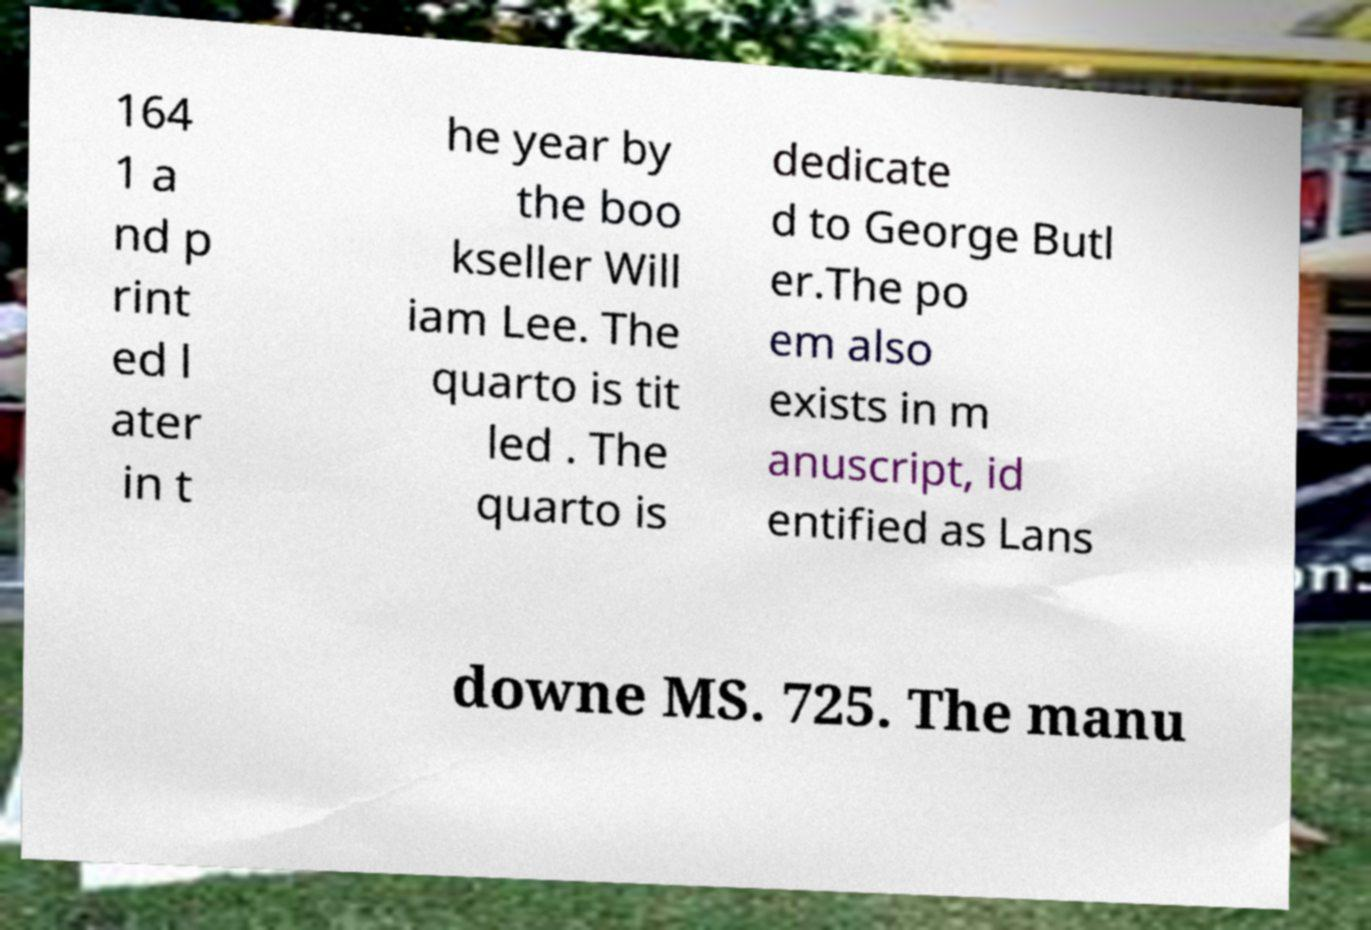I need the written content from this picture converted into text. Can you do that? 164 1 a nd p rint ed l ater in t he year by the boo kseller Will iam Lee. The quarto is tit led . The quarto is dedicate d to George Butl er.The po em also exists in m anuscript, id entified as Lans downe MS. 725. The manu 